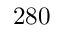<formula> <loc_0><loc_0><loc_500><loc_500>2 8 0</formula> 